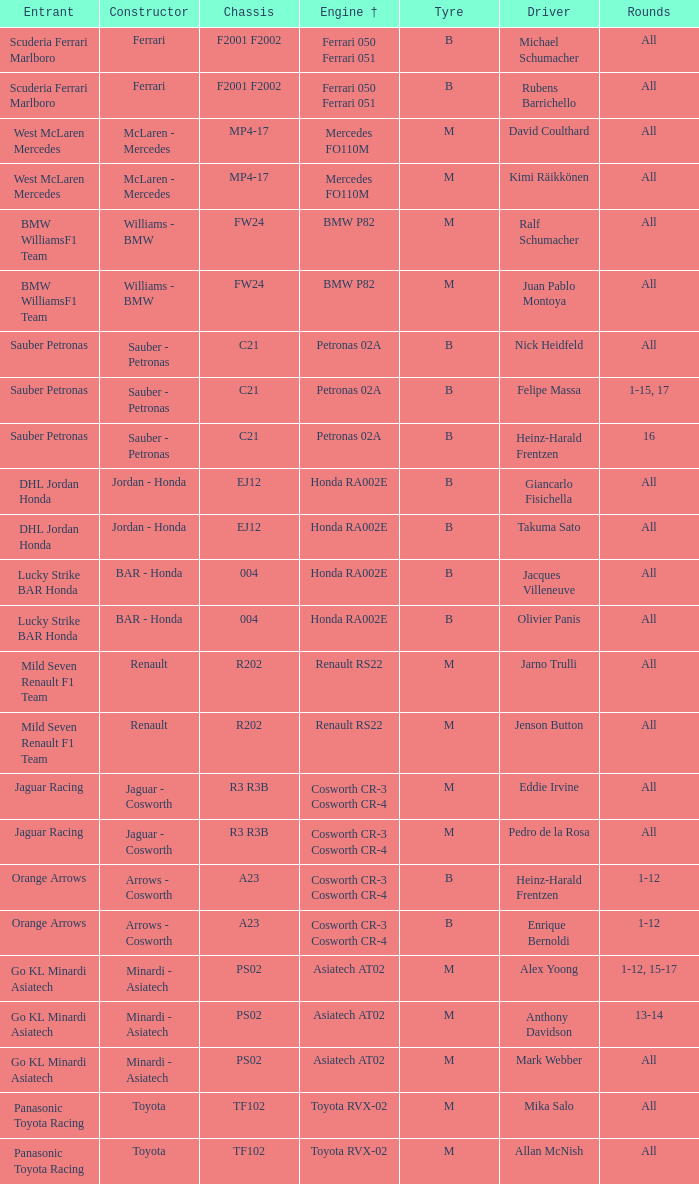What is the rounds when the engine is mercedes fo110m? All, All. 